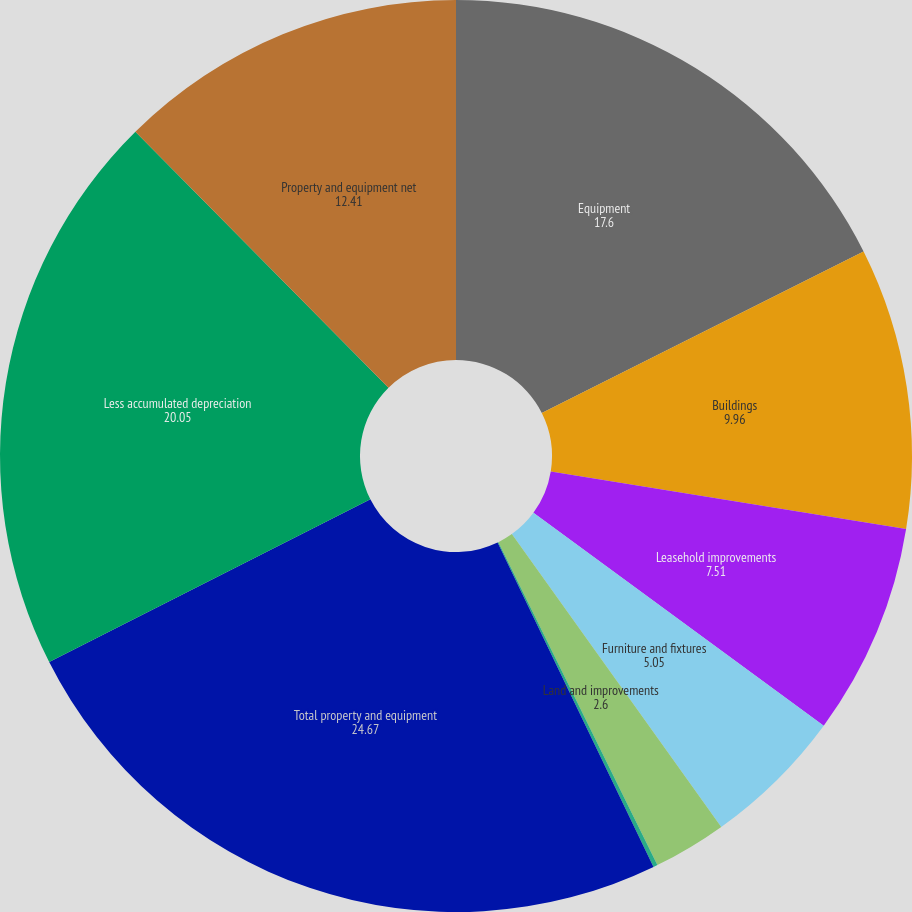<chart> <loc_0><loc_0><loc_500><loc_500><pie_chart><fcel>Equipment<fcel>Buildings<fcel>Leasehold improvements<fcel>Furniture and fixtures<fcel>Land and improvements<fcel>Projects in process<fcel>Total property and equipment<fcel>Less accumulated depreciation<fcel>Property and equipment net<nl><fcel>17.6%<fcel>9.96%<fcel>7.51%<fcel>5.05%<fcel>2.6%<fcel>0.15%<fcel>24.67%<fcel>20.05%<fcel>12.41%<nl></chart> 